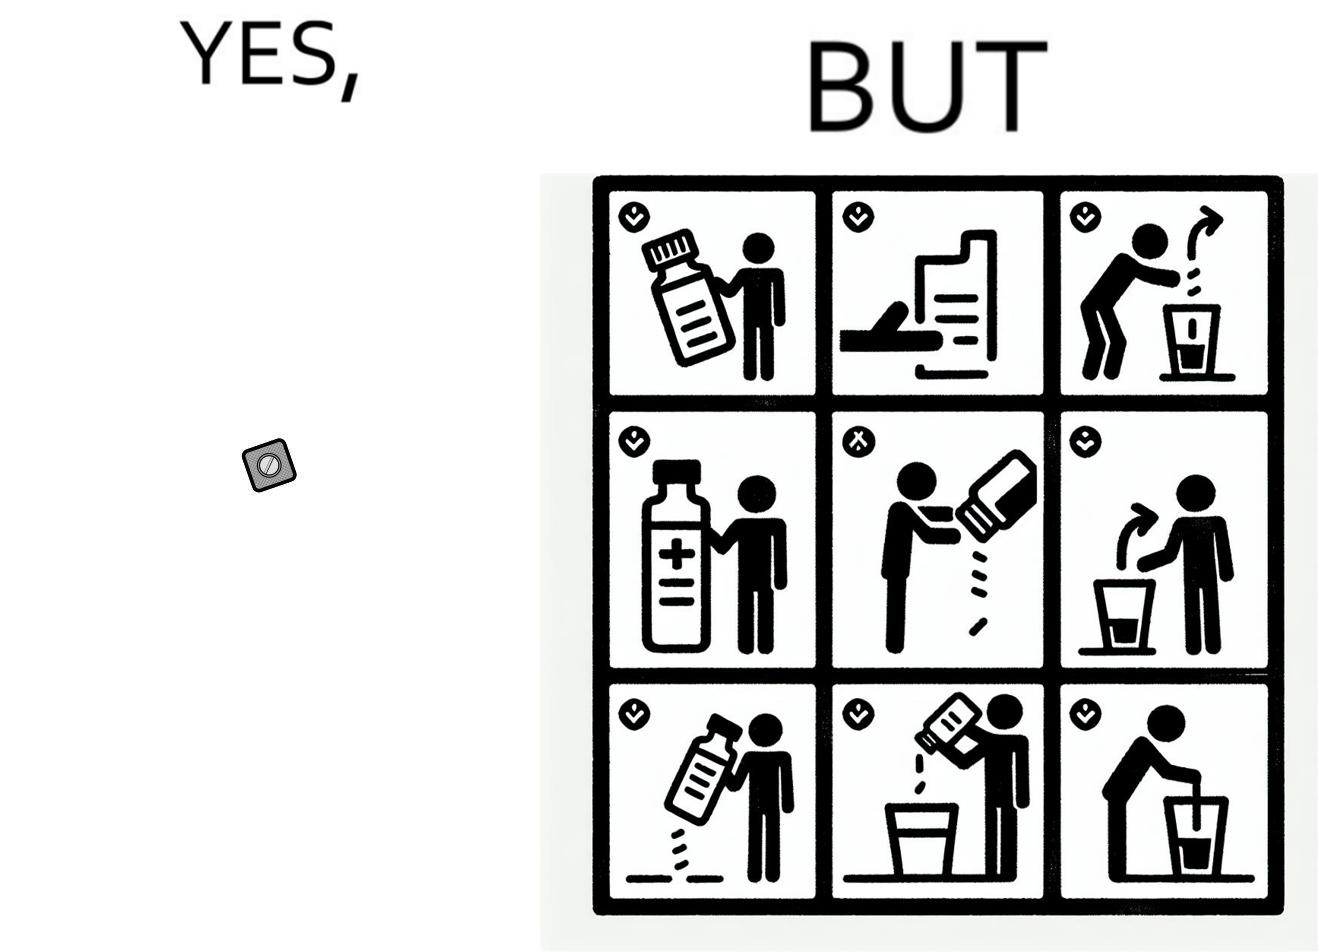Is this a satirical image? Yes, this image is satirical. 